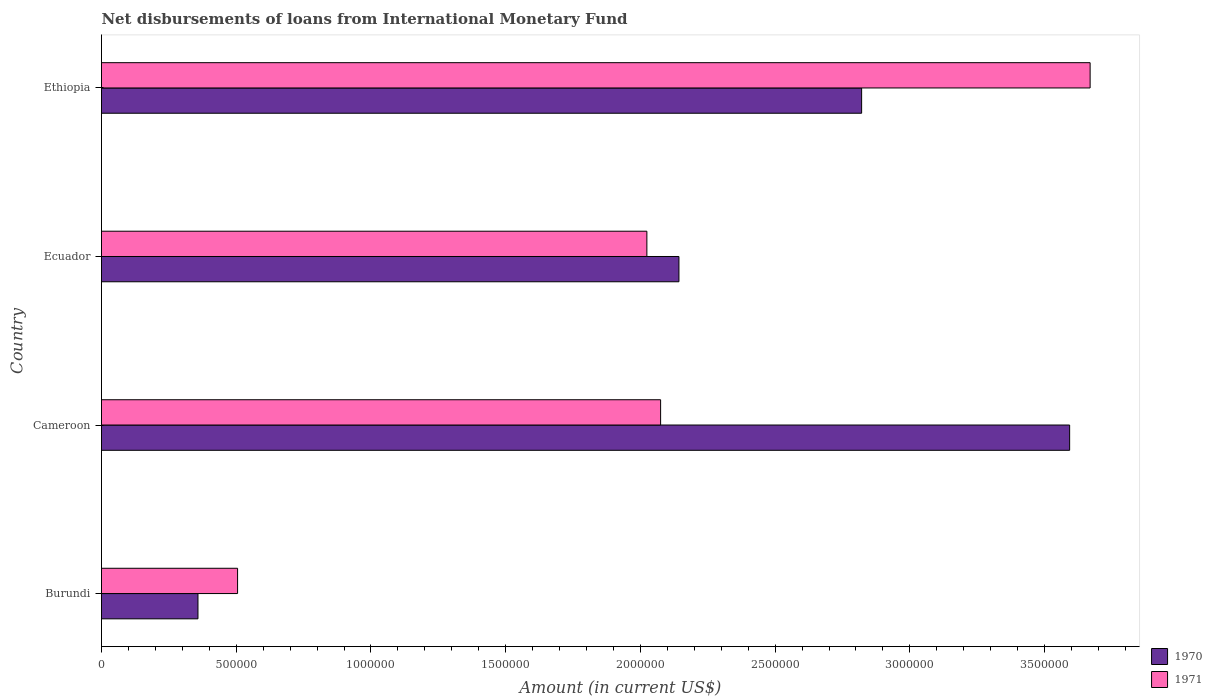How many groups of bars are there?
Ensure brevity in your answer.  4. Are the number of bars per tick equal to the number of legend labels?
Give a very brief answer. Yes. How many bars are there on the 4th tick from the top?
Offer a very short reply. 2. How many bars are there on the 4th tick from the bottom?
Give a very brief answer. 2. What is the label of the 1st group of bars from the top?
Make the answer very short. Ethiopia. What is the amount of loans disbursed in 1970 in Ecuador?
Provide a short and direct response. 2.14e+06. Across all countries, what is the maximum amount of loans disbursed in 1970?
Keep it short and to the point. 3.59e+06. Across all countries, what is the minimum amount of loans disbursed in 1971?
Your answer should be compact. 5.05e+05. In which country was the amount of loans disbursed in 1971 maximum?
Offer a very short reply. Ethiopia. In which country was the amount of loans disbursed in 1970 minimum?
Your response must be concise. Burundi. What is the total amount of loans disbursed in 1971 in the graph?
Keep it short and to the point. 8.27e+06. What is the difference between the amount of loans disbursed in 1971 in Ecuador and that in Ethiopia?
Offer a very short reply. -1.64e+06. What is the difference between the amount of loans disbursed in 1970 in Burundi and the amount of loans disbursed in 1971 in Cameroon?
Provide a succinct answer. -1.72e+06. What is the average amount of loans disbursed in 1970 per country?
Provide a succinct answer. 2.23e+06. What is the difference between the amount of loans disbursed in 1971 and amount of loans disbursed in 1970 in Cameroon?
Offer a very short reply. -1.52e+06. In how many countries, is the amount of loans disbursed in 1970 greater than 900000 US$?
Your response must be concise. 3. What is the ratio of the amount of loans disbursed in 1970 in Cameroon to that in Ecuador?
Keep it short and to the point. 1.68. What is the difference between the highest and the second highest amount of loans disbursed in 1971?
Provide a succinct answer. 1.59e+06. What is the difference between the highest and the lowest amount of loans disbursed in 1970?
Provide a succinct answer. 3.24e+06. What does the 2nd bar from the bottom in Ethiopia represents?
Give a very brief answer. 1971. Does the graph contain any zero values?
Offer a very short reply. No. Does the graph contain grids?
Your answer should be compact. No. How are the legend labels stacked?
Ensure brevity in your answer.  Vertical. What is the title of the graph?
Provide a succinct answer. Net disbursements of loans from International Monetary Fund. What is the label or title of the X-axis?
Provide a short and direct response. Amount (in current US$). What is the label or title of the Y-axis?
Provide a short and direct response. Country. What is the Amount (in current US$) in 1970 in Burundi?
Your answer should be very brief. 3.58e+05. What is the Amount (in current US$) of 1971 in Burundi?
Ensure brevity in your answer.  5.05e+05. What is the Amount (in current US$) in 1970 in Cameroon?
Make the answer very short. 3.59e+06. What is the Amount (in current US$) in 1971 in Cameroon?
Your response must be concise. 2.08e+06. What is the Amount (in current US$) in 1970 in Ecuador?
Ensure brevity in your answer.  2.14e+06. What is the Amount (in current US$) of 1971 in Ecuador?
Ensure brevity in your answer.  2.02e+06. What is the Amount (in current US$) of 1970 in Ethiopia?
Provide a short and direct response. 2.82e+06. What is the Amount (in current US$) in 1971 in Ethiopia?
Offer a very short reply. 3.67e+06. Across all countries, what is the maximum Amount (in current US$) in 1970?
Your answer should be compact. 3.59e+06. Across all countries, what is the maximum Amount (in current US$) of 1971?
Keep it short and to the point. 3.67e+06. Across all countries, what is the minimum Amount (in current US$) of 1970?
Make the answer very short. 3.58e+05. Across all countries, what is the minimum Amount (in current US$) of 1971?
Provide a succinct answer. 5.05e+05. What is the total Amount (in current US$) of 1970 in the graph?
Provide a succinct answer. 8.92e+06. What is the total Amount (in current US$) of 1971 in the graph?
Offer a terse response. 8.27e+06. What is the difference between the Amount (in current US$) in 1970 in Burundi and that in Cameroon?
Offer a terse response. -3.24e+06. What is the difference between the Amount (in current US$) of 1971 in Burundi and that in Cameroon?
Your response must be concise. -1.57e+06. What is the difference between the Amount (in current US$) of 1970 in Burundi and that in Ecuador?
Your answer should be compact. -1.78e+06. What is the difference between the Amount (in current US$) in 1971 in Burundi and that in Ecuador?
Provide a short and direct response. -1.52e+06. What is the difference between the Amount (in current US$) of 1970 in Burundi and that in Ethiopia?
Make the answer very short. -2.46e+06. What is the difference between the Amount (in current US$) in 1971 in Burundi and that in Ethiopia?
Your response must be concise. -3.16e+06. What is the difference between the Amount (in current US$) in 1970 in Cameroon and that in Ecuador?
Ensure brevity in your answer.  1.45e+06. What is the difference between the Amount (in current US$) in 1971 in Cameroon and that in Ecuador?
Your response must be concise. 5.10e+04. What is the difference between the Amount (in current US$) in 1970 in Cameroon and that in Ethiopia?
Give a very brief answer. 7.72e+05. What is the difference between the Amount (in current US$) of 1971 in Cameroon and that in Ethiopia?
Your answer should be very brief. -1.59e+06. What is the difference between the Amount (in current US$) in 1970 in Ecuador and that in Ethiopia?
Provide a short and direct response. -6.78e+05. What is the difference between the Amount (in current US$) in 1971 in Ecuador and that in Ethiopia?
Give a very brief answer. -1.64e+06. What is the difference between the Amount (in current US$) in 1970 in Burundi and the Amount (in current US$) in 1971 in Cameroon?
Provide a succinct answer. -1.72e+06. What is the difference between the Amount (in current US$) in 1970 in Burundi and the Amount (in current US$) in 1971 in Ecuador?
Ensure brevity in your answer.  -1.67e+06. What is the difference between the Amount (in current US$) in 1970 in Burundi and the Amount (in current US$) in 1971 in Ethiopia?
Make the answer very short. -3.31e+06. What is the difference between the Amount (in current US$) of 1970 in Cameroon and the Amount (in current US$) of 1971 in Ecuador?
Offer a terse response. 1.57e+06. What is the difference between the Amount (in current US$) in 1970 in Cameroon and the Amount (in current US$) in 1971 in Ethiopia?
Your answer should be compact. -7.60e+04. What is the difference between the Amount (in current US$) of 1970 in Ecuador and the Amount (in current US$) of 1971 in Ethiopia?
Your response must be concise. -1.53e+06. What is the average Amount (in current US$) in 1970 per country?
Your answer should be compact. 2.23e+06. What is the average Amount (in current US$) in 1971 per country?
Your response must be concise. 2.07e+06. What is the difference between the Amount (in current US$) of 1970 and Amount (in current US$) of 1971 in Burundi?
Offer a terse response. -1.47e+05. What is the difference between the Amount (in current US$) of 1970 and Amount (in current US$) of 1971 in Cameroon?
Give a very brief answer. 1.52e+06. What is the difference between the Amount (in current US$) in 1970 and Amount (in current US$) in 1971 in Ecuador?
Your answer should be very brief. 1.19e+05. What is the difference between the Amount (in current US$) in 1970 and Amount (in current US$) in 1971 in Ethiopia?
Make the answer very short. -8.48e+05. What is the ratio of the Amount (in current US$) of 1970 in Burundi to that in Cameroon?
Your response must be concise. 0.1. What is the ratio of the Amount (in current US$) of 1971 in Burundi to that in Cameroon?
Keep it short and to the point. 0.24. What is the ratio of the Amount (in current US$) in 1970 in Burundi to that in Ecuador?
Your answer should be very brief. 0.17. What is the ratio of the Amount (in current US$) of 1971 in Burundi to that in Ecuador?
Provide a short and direct response. 0.25. What is the ratio of the Amount (in current US$) in 1970 in Burundi to that in Ethiopia?
Make the answer very short. 0.13. What is the ratio of the Amount (in current US$) in 1971 in Burundi to that in Ethiopia?
Make the answer very short. 0.14. What is the ratio of the Amount (in current US$) in 1970 in Cameroon to that in Ecuador?
Your answer should be compact. 1.68. What is the ratio of the Amount (in current US$) in 1971 in Cameroon to that in Ecuador?
Ensure brevity in your answer.  1.03. What is the ratio of the Amount (in current US$) of 1970 in Cameroon to that in Ethiopia?
Offer a terse response. 1.27. What is the ratio of the Amount (in current US$) in 1971 in Cameroon to that in Ethiopia?
Provide a short and direct response. 0.57. What is the ratio of the Amount (in current US$) in 1970 in Ecuador to that in Ethiopia?
Your answer should be compact. 0.76. What is the ratio of the Amount (in current US$) in 1971 in Ecuador to that in Ethiopia?
Give a very brief answer. 0.55. What is the difference between the highest and the second highest Amount (in current US$) in 1970?
Provide a short and direct response. 7.72e+05. What is the difference between the highest and the second highest Amount (in current US$) in 1971?
Your answer should be compact. 1.59e+06. What is the difference between the highest and the lowest Amount (in current US$) of 1970?
Provide a succinct answer. 3.24e+06. What is the difference between the highest and the lowest Amount (in current US$) in 1971?
Offer a very short reply. 3.16e+06. 